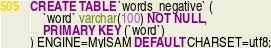<code> <loc_0><loc_0><loc_500><loc_500><_SQL_>CREATE TABLE `words_negative` (
    `word` varchar(100) NOT NULL,
    PRIMARY KEY (`word`)
) ENGINE=MyISAM DEFAULT CHARSET=utf8;
</code> 